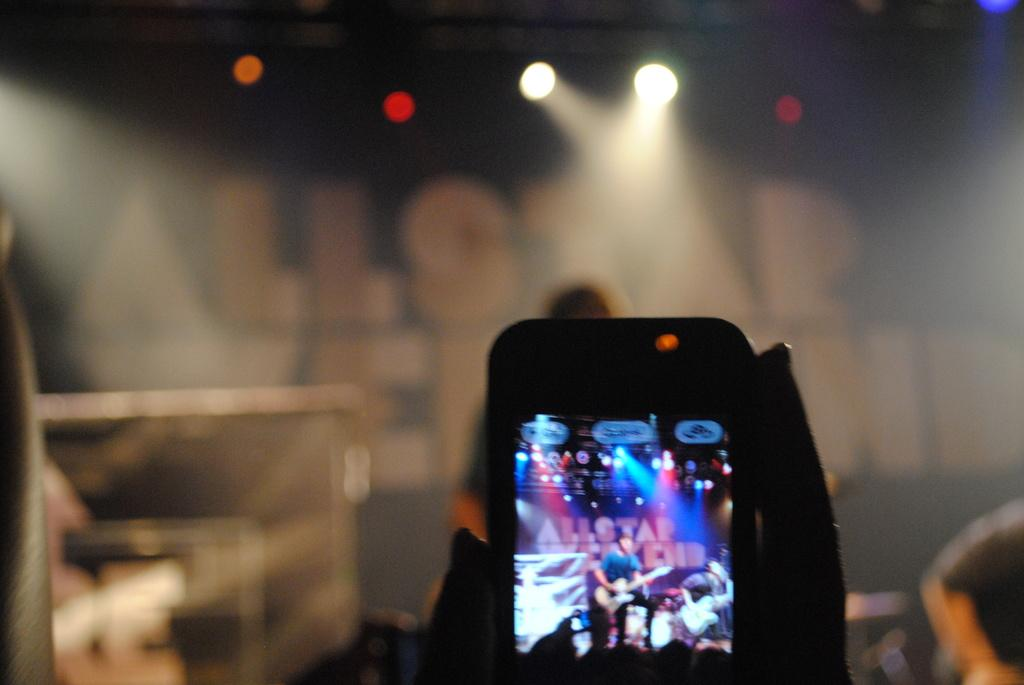What is the main object in the center of the image? There is a video camera in the center of the image. What is happening in the background of the image? There is a person performing in the background. Where is the performance taking place? The performance is taking place on a dash. What can be seen illuminated in the background? There are lights visible in the background. What type of structure is present in the background? There is a wall in the background. Where is the shelf located in the image? There is no shelf present in the image. What type of sea creature can be seen swimming in the background? There is no sea creature present in the image; it is a performance taking place on a dash with a wall in the background. 